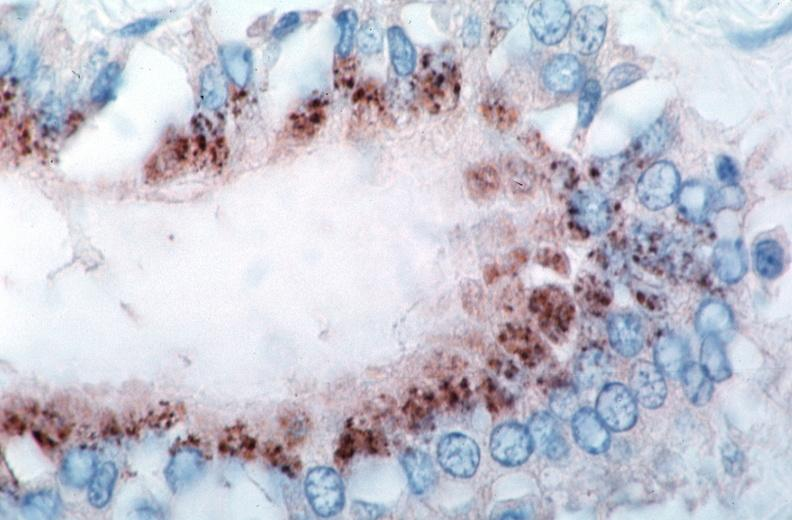s rocky mountain spotted fever, immunoperoxidase staining vessels for rickettsia rickettsii?
Answer the question using a single word or phrase. Yes 